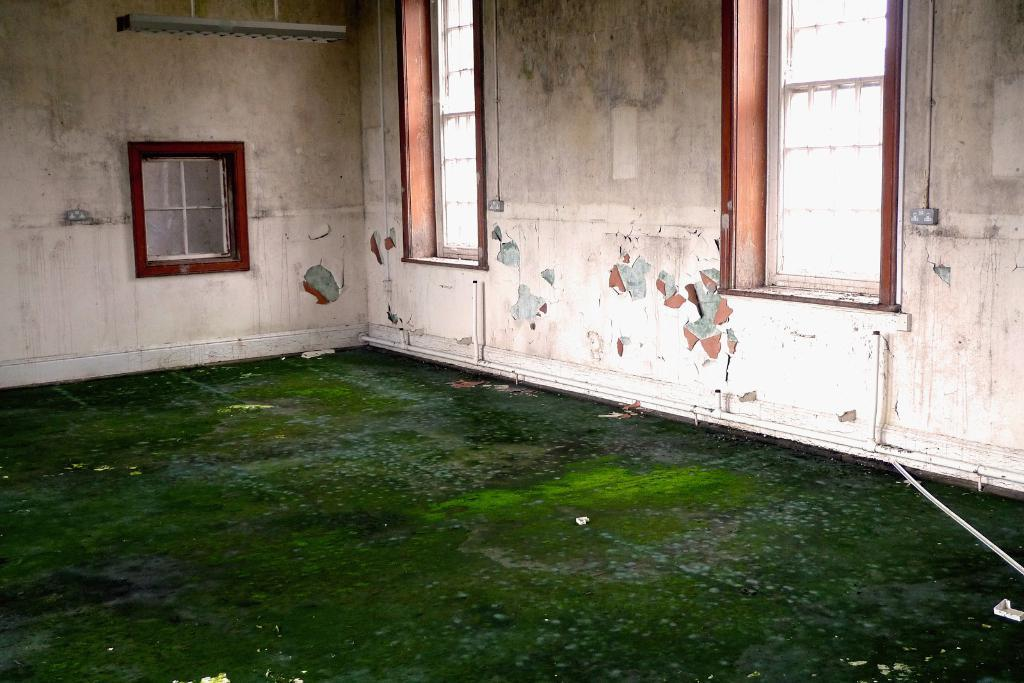What type of space is shown in the image? There is a room in the image. What feature of the room allows natural light to enter? There are windows in the room. Where are the windows located within the room? The windows are on the wall. What can be seen outside of the room in the image? There is a road visible in the image. How is the road positioned in relation to the room? The road is at the top of the image. Can you see a tiger walking on the road in the image? No, there is no tiger present in the image. What type of straw is being used to decorate the room in the image? There is no straw visible in the image, and no decorations are mentioned in the provided facts. 